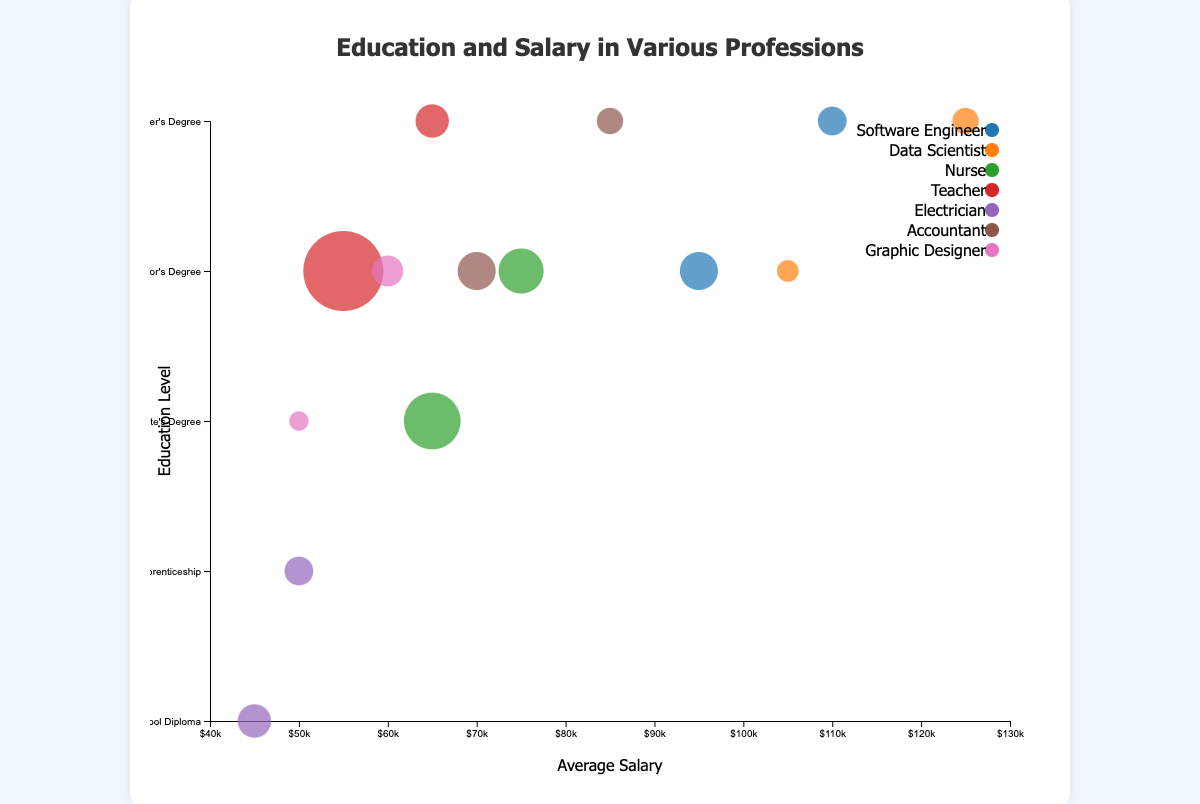What's the title of the graph? The title is located at the top of the chart and states the main subject of the figure. It reads "Education and Salary in Various Professions"
Answer: Education and Salary in Various Professions Which profession has the highest average salary for a Master's Degree according to the chart? Look at the y-axis and find the point corresponding to the Master's Degree. Among the professions listed there, Data Scientist points to the highest average salary bubble when looking at the x-axis values.
Answer: Data Scientist What profession and education level have the largest number of professionals? The size of the bubbles represents the number of professionals in each category. The largest bubble in the chart represents Nurses with an Associate’s Degree.
Answer: Nurse with Associate’s Degree How many professions are represented in the chart? The legend at the right side of the chart lists the professions by different colors in the bubbles. Counting them results in the total number of professions. The professions listed are Software Engineer, Data Scientist, Nurse, Teacher, Electrician, Accountant, and Graphic Designer.
Answer: 7 What is the average salary of Electricians with an Apprenticeship compared to those with a High School Diploma? Locate the two bubbles representing Electricians with different education levels. Compare their x-axis positions. The bubble with Apprenticeship is at $50,000 and the one with a High School Diploma is at $45,000.
Answer: $50,000 (Apprenticeship) and $45,000 (High School Diploma) Which group of Teachers earns more on average, those with a Bachelor's Degree or those with a Master's Degree? Find the bubbles for Teachers. Compare their x-axis positions, looking at the Bachelor's Degree and Master's Degree bubbles. The Master's Degree bubble has a higher x-axis value (salary).
Answer: Master's Degree For which education level do Nurses have an average salary higher than the average salary of Teachers with the same education level? Locate the bubbles representing Nurses and Teachers. Compare their positions on the x-axis for each shared education level. Nurses with a Bachelor's Degree earn more on average than Teachers with a Bachelor's Degree.
Answer: Bachelor's Degree Which profession has a larger difference in average salary between a Bachelor's Degree and a Master's Degree: Software Engineer or Data Scientist? Calculate the salary difference for both professions by subtracting the salary of a Bachelor's Degree from that of a Master's Degree for both professions. Software Engineer difference: $110,000 - $95,000 = $15,000; Data Scientist difference: $125,000 - $105,000 = $20,000
Answer: Data Scientist What does the y-axis represent in this chart? The axis to the left of the chart lists various education levels. These levels range from "High School Diploma" at the bottom to "Master's Degree" at the top.
Answer: Education level What's the color of the bubbles representing Accountants? Refer to the legend on the right side of the chart, where colors are matched with professions. The bubbles for Accountants are colored accordingly.
Answer: Usually unique per the palette, likely a specific color mentioned in the legend 